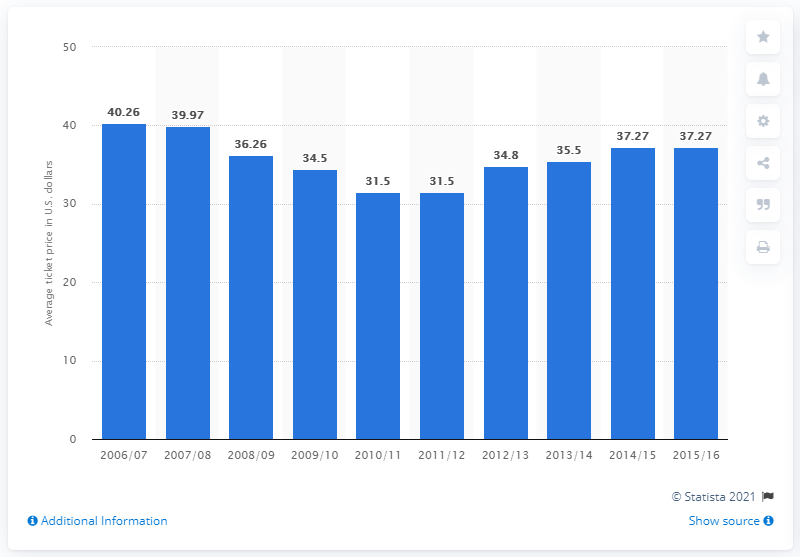Indicate a few pertinent items in this graphic. The average ticket price for Minnesota Timberwolves games in the 2006/2007 season was $40.26. 